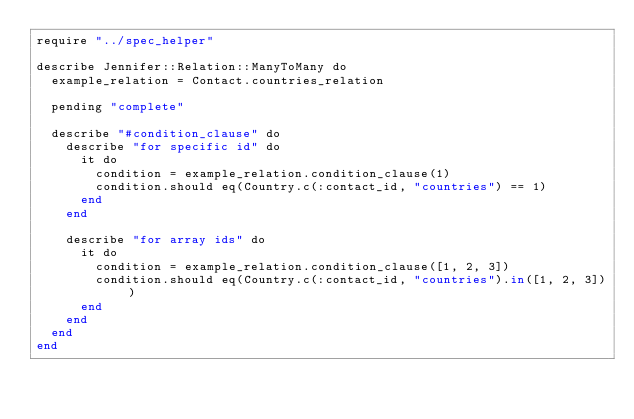<code> <loc_0><loc_0><loc_500><loc_500><_Crystal_>require "../spec_helper"

describe Jennifer::Relation::ManyToMany do
  example_relation = Contact.countries_relation

  pending "complete"

  describe "#condition_clause" do
    describe "for specific id" do
      it do
        condition = example_relation.condition_clause(1)
        condition.should eq(Country.c(:contact_id, "countries") == 1)
      end
    end

    describe "for array ids" do
      it do
        condition = example_relation.condition_clause([1, 2, 3])
        condition.should eq(Country.c(:contact_id, "countries").in([1, 2, 3]))
      end
    end
  end
end
</code> 